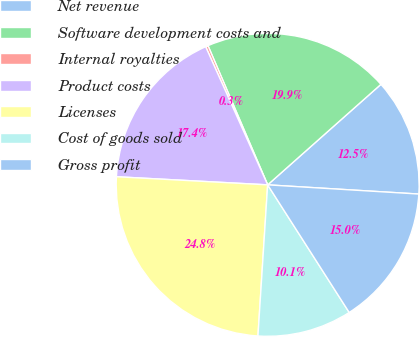Convert chart to OTSL. <chart><loc_0><loc_0><loc_500><loc_500><pie_chart><fcel>Net revenue<fcel>Software development costs and<fcel>Internal royalties<fcel>Product costs<fcel>Licenses<fcel>Cost of goods sold<fcel>Gross profit<nl><fcel>12.52%<fcel>19.89%<fcel>0.27%<fcel>17.43%<fcel>24.83%<fcel>10.07%<fcel>14.98%<nl></chart> 